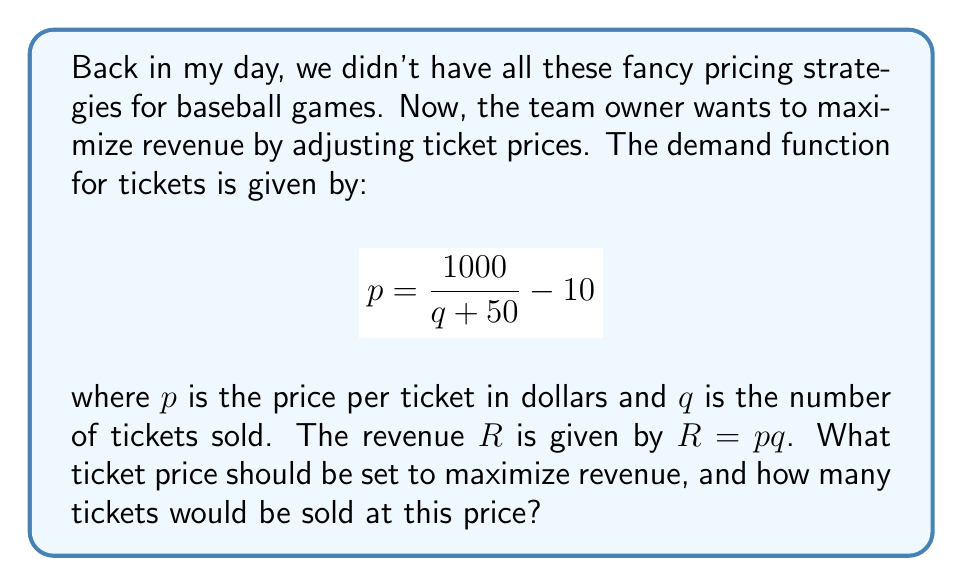Provide a solution to this math problem. Let's approach this step-by-step:

1) First, we need to express revenue $R$ in terms of $q$:
   $$R = pq = \left(\frac{1000}{q + 50} - 10\right)q$$

2) Simplify this expression:
   $$R = \frac{1000q}{q + 50} - 10q$$

3) To find the maximum revenue, we need to differentiate $R$ with respect to $q$ and set it equal to zero:
   $$\frac{dR}{dq} = \frac{1000(q + 50) - 1000q}{(q + 50)^2} - 10 = 0$$

4) Simplify:
   $$\frac{50000}{(q + 50)^2} - 10 = 0$$

5) Solve for $q$:
   $$\frac{50000}{(q + 50)^2} = 10$$
   $$(q + 50)^2 = 5000$$
   $$q + 50 = \sqrt{5000} \approx 70.71$$
   $$q \approx 20.71$$

6) Since $q$ represents the number of tickets, we round to 21 tickets.

7) To find the price, substitute $q = 21$ into the original demand function:
   $$p = \frac{1000}{21 + 50} - 10 = \frac{1000}{71} - 10 \approx 4.08$$

8) Rounding to the nearest cent, the price should be set at $4.08 per ticket.
Answer: $4.08 per ticket; 21 tickets 